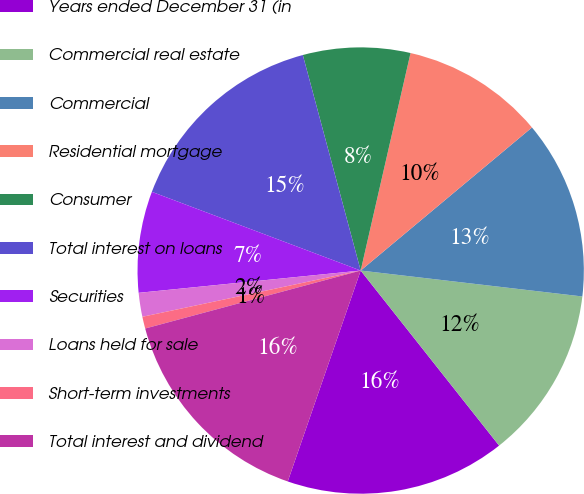<chart> <loc_0><loc_0><loc_500><loc_500><pie_chart><fcel>Years ended December 31 (in<fcel>Commercial real estate<fcel>Commercial<fcel>Residential mortgage<fcel>Consumer<fcel>Total interest on loans<fcel>Securities<fcel>Loans held for sale<fcel>Short-term investments<fcel>Total interest and dividend<nl><fcel>15.95%<fcel>12.5%<fcel>12.93%<fcel>10.34%<fcel>7.76%<fcel>15.09%<fcel>7.33%<fcel>1.73%<fcel>0.86%<fcel>15.52%<nl></chart> 